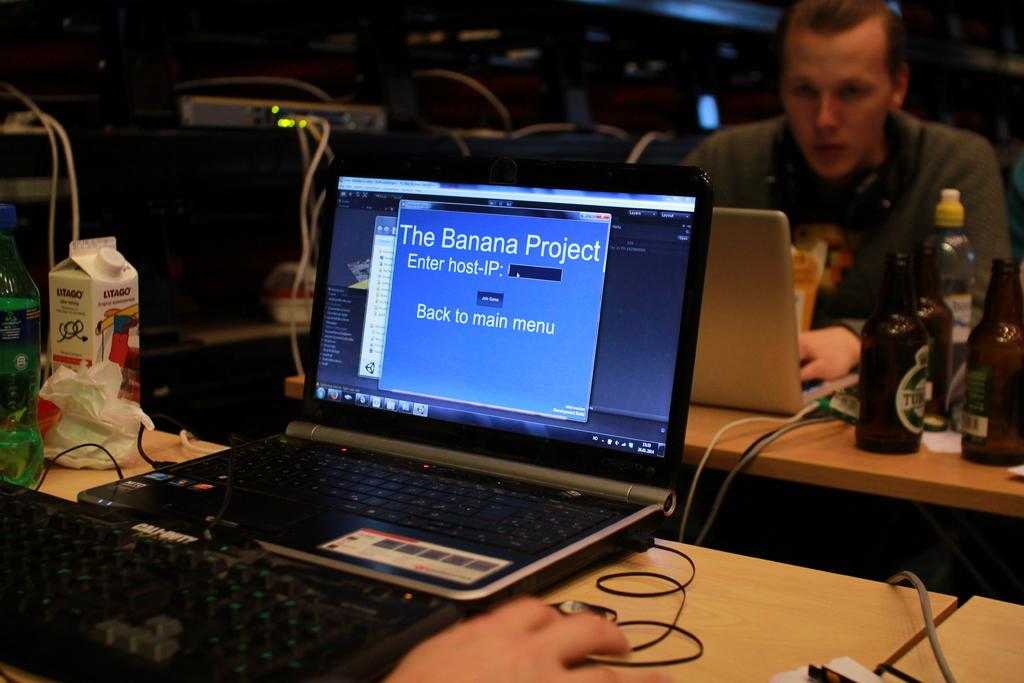<image>
Describe the image concisely. A laptop is open with a display stating, "The Banana Project." 